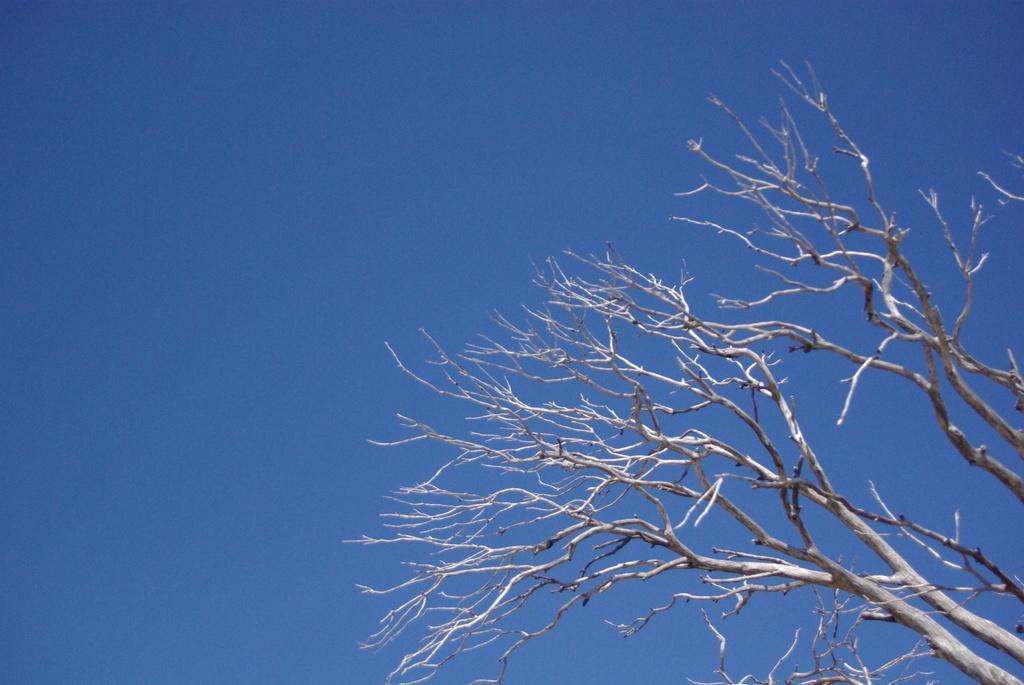Please provide a concise description of this image. In the image there are branches of a dry tree. 